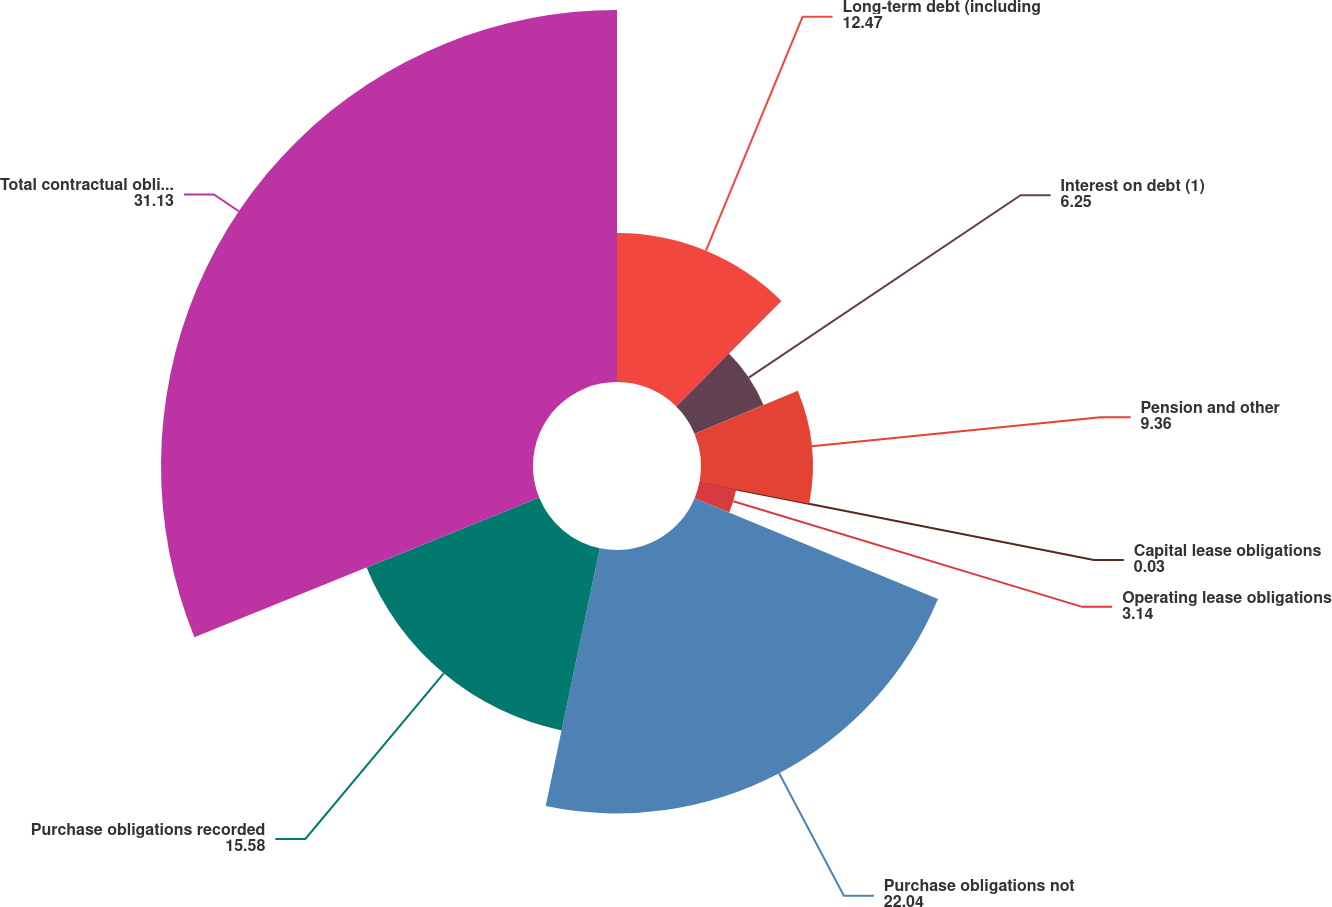Convert chart. <chart><loc_0><loc_0><loc_500><loc_500><pie_chart><fcel>Long-term debt (including<fcel>Interest on debt (1)<fcel>Pension and other<fcel>Capital lease obligations<fcel>Operating lease obligations<fcel>Purchase obligations not<fcel>Purchase obligations recorded<fcel>Total contractual obligations<nl><fcel>12.47%<fcel>6.25%<fcel>9.36%<fcel>0.03%<fcel>3.14%<fcel>22.04%<fcel>15.58%<fcel>31.13%<nl></chart> 